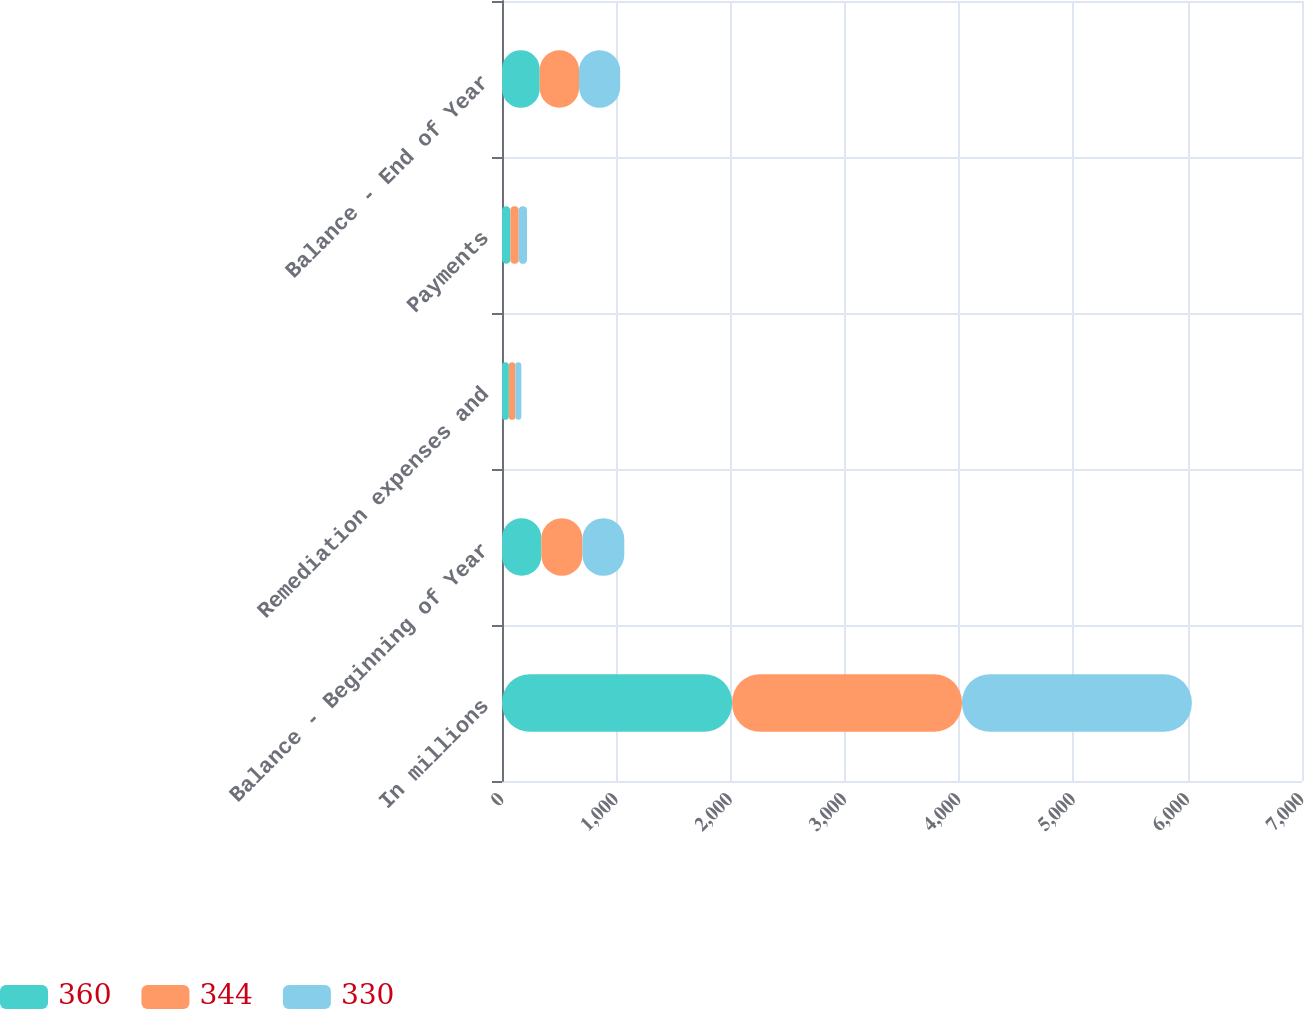Convert chart. <chart><loc_0><loc_0><loc_500><loc_500><stacked_bar_chart><ecel><fcel>In millions<fcel>Balance - Beginning of Year<fcel>Remediation expenses and<fcel>Payments<fcel>Balance - End of Year<nl><fcel>360<fcel>2013<fcel>344<fcel>60<fcel>74<fcel>330<nl><fcel>344<fcel>2012<fcel>360<fcel>56<fcel>72<fcel>344<nl><fcel>330<fcel>2011<fcel>366<fcel>53<fcel>73<fcel>360<nl></chart> 